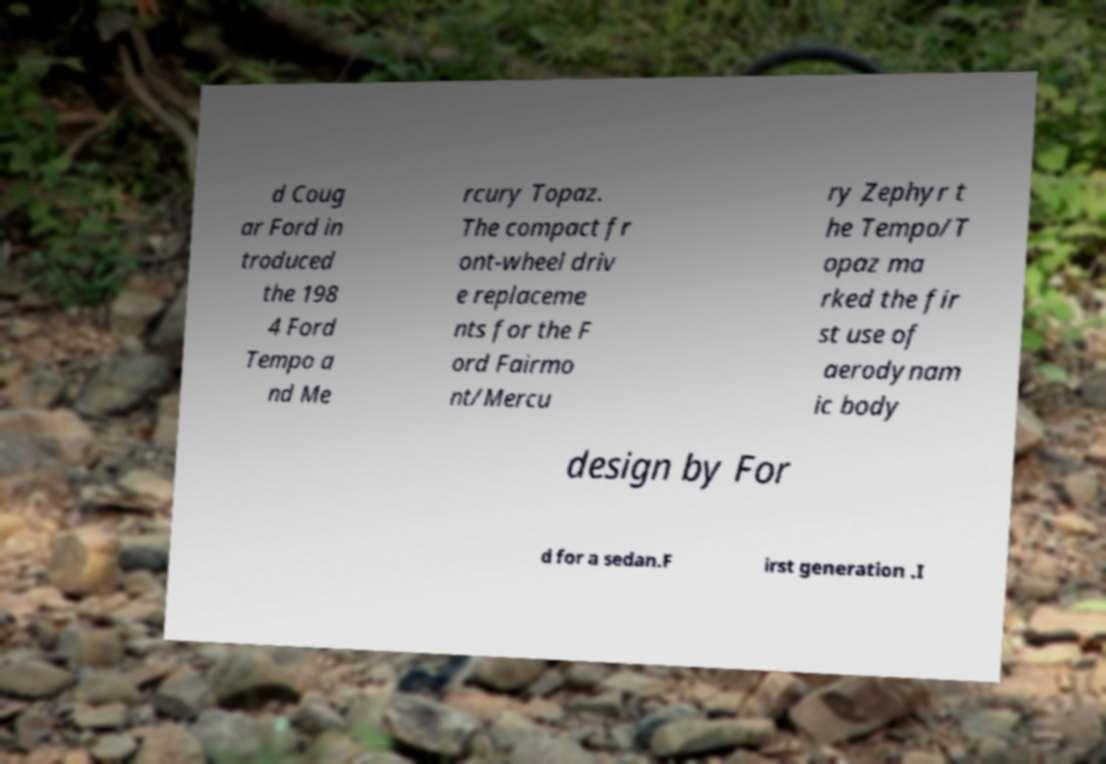Please identify and transcribe the text found in this image. d Coug ar Ford in troduced the 198 4 Ford Tempo a nd Me rcury Topaz. The compact fr ont-wheel driv e replaceme nts for the F ord Fairmo nt/Mercu ry Zephyr t he Tempo/T opaz ma rked the fir st use of aerodynam ic body design by For d for a sedan.F irst generation .I 